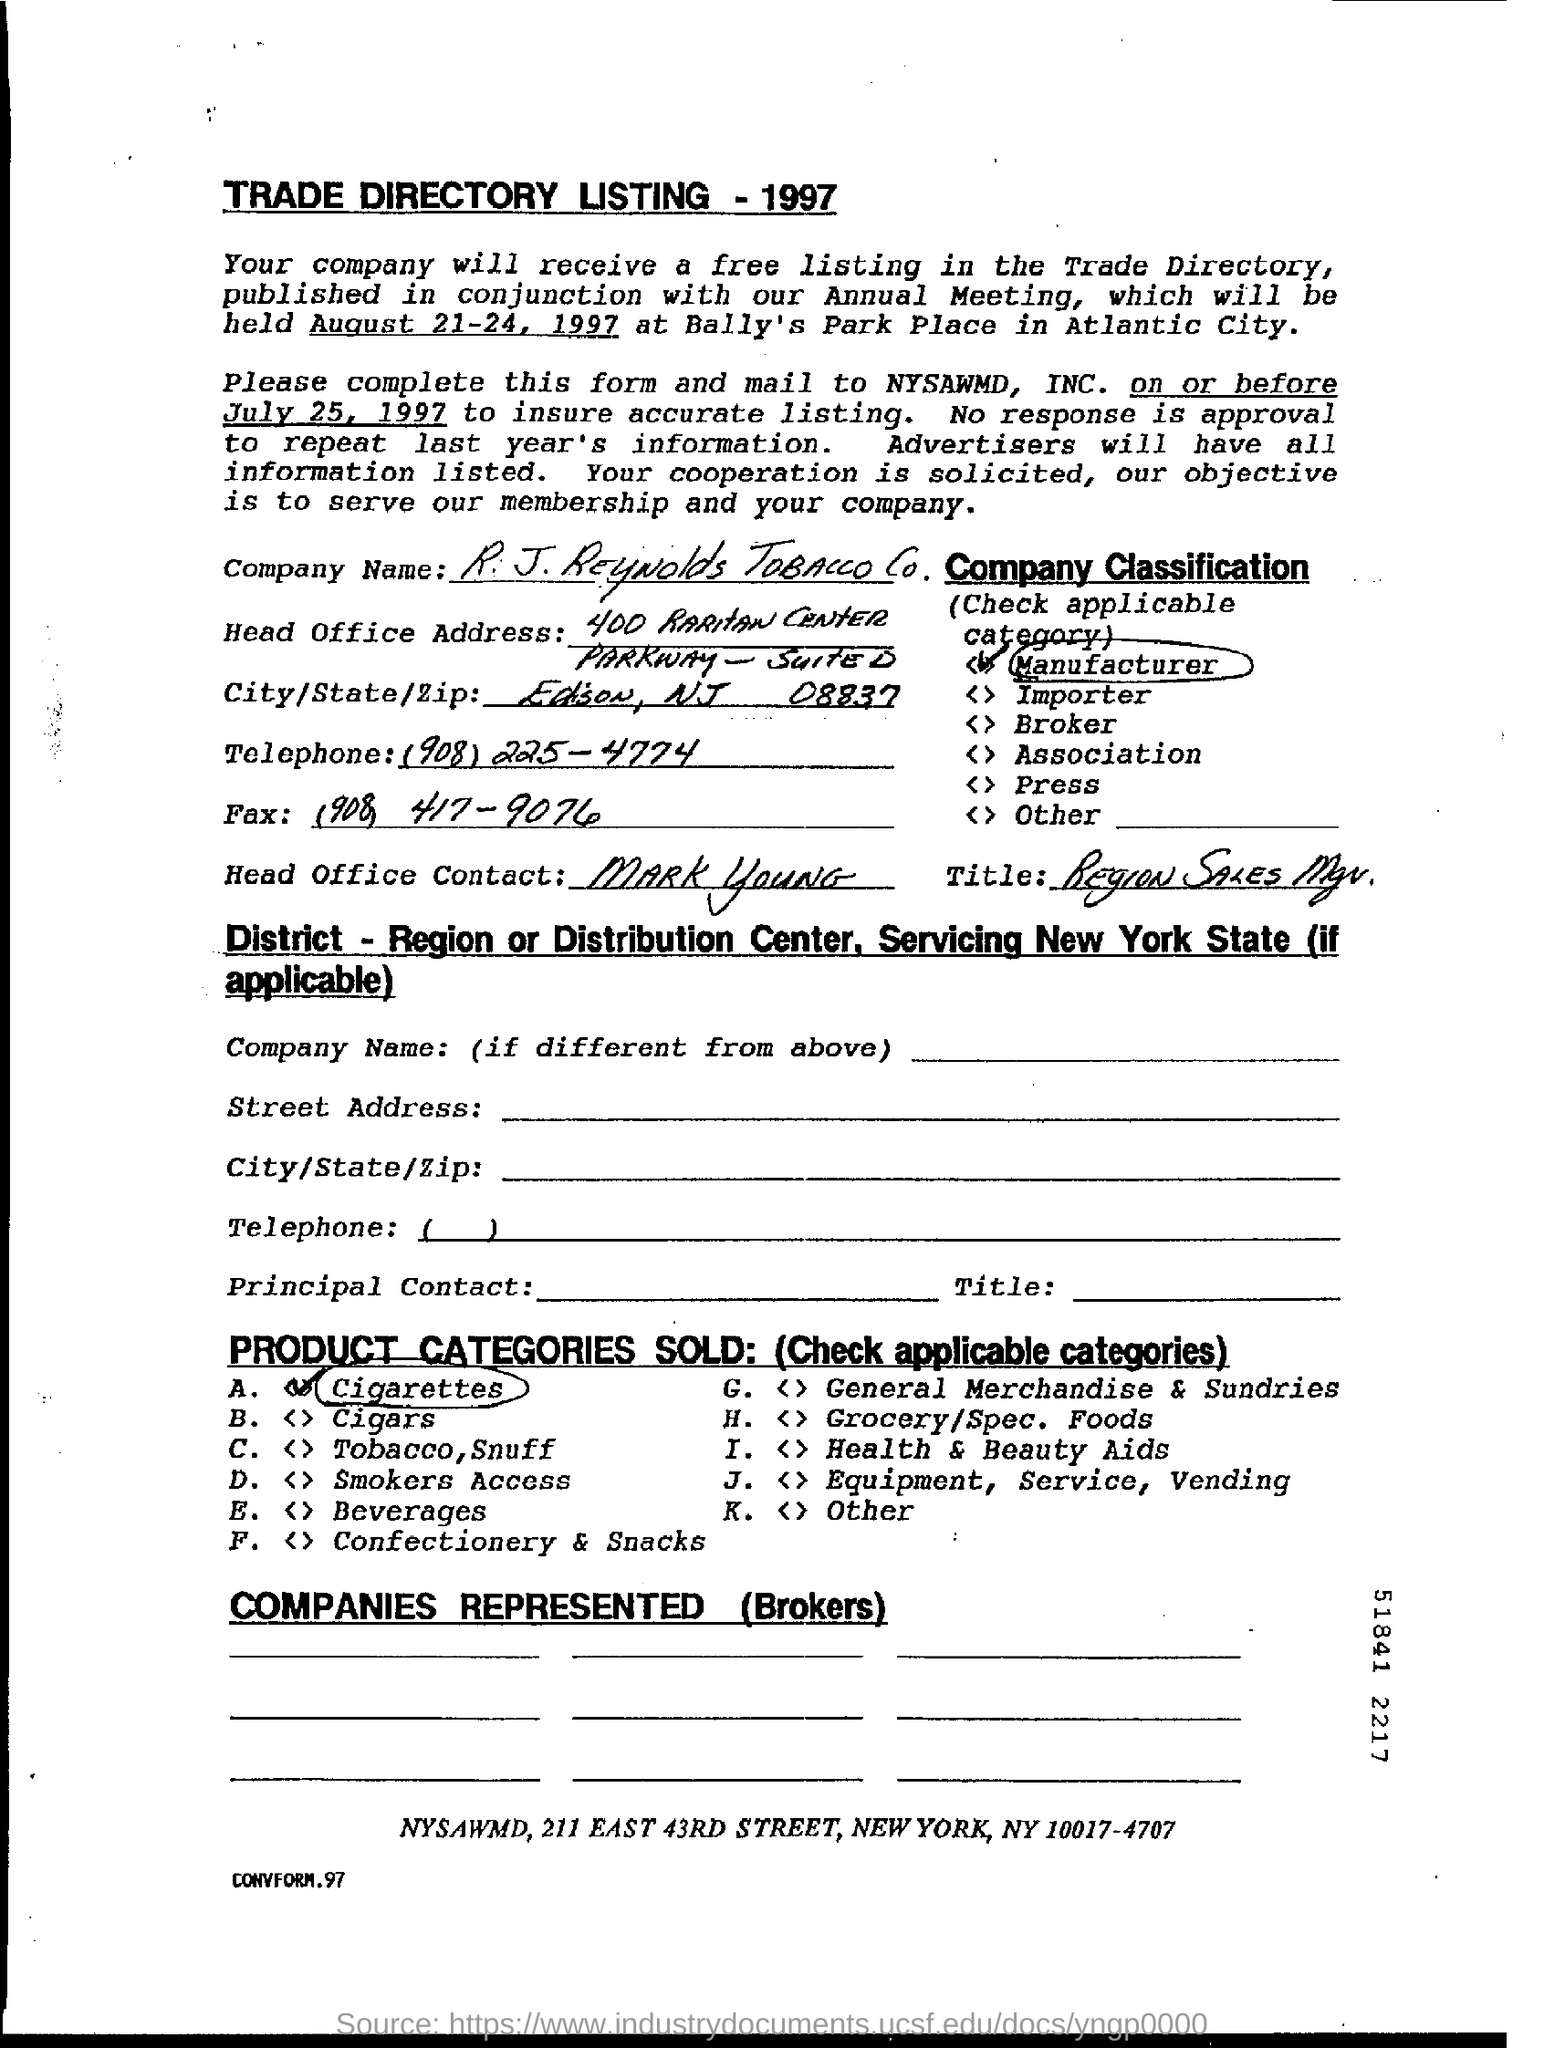What is the company name?
Keep it short and to the point. R.J. Reynolds tobacco co. What is the City/State/Zip?
Your answer should be compact. Edison, NJ 08837. What is the Telephone?
Offer a very short reply. (908) 225-4774. What is the Fax number filled in this form?
Your answer should be very brief. (908) 417-9076. Who is the head office contact?
Your answer should be very brief. Mark young. What is the "Title"?
Keep it short and to the point. Region Sales Mgr. 